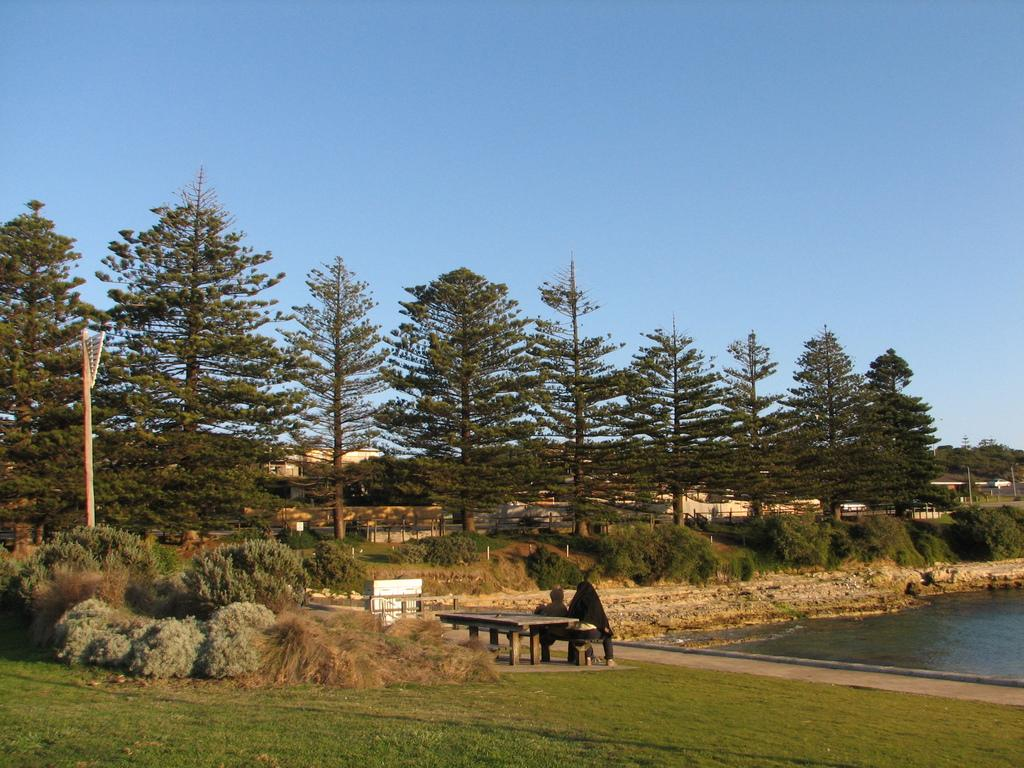How many people are sitting on the bench in the image? There are two persons sitting on a bench in the image. What is the location of the bench in the image? The bench is on a grassland in the image. What can be seen on the right side of the image? There is a pond on the right side of the image. What is visible in the background of the image? Trees are present in the background of the image. What is visible above the scene in the image? The sky is visible above the scene in the image. What type of credit card is the person on the left using in the image? There is no credit card or any indication of a financial transaction in the image. 